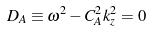<formula> <loc_0><loc_0><loc_500><loc_500>D _ { A } \equiv \omega ^ { 2 } - C _ { A } ^ { 2 } k _ { z } ^ { 2 } = 0</formula> 